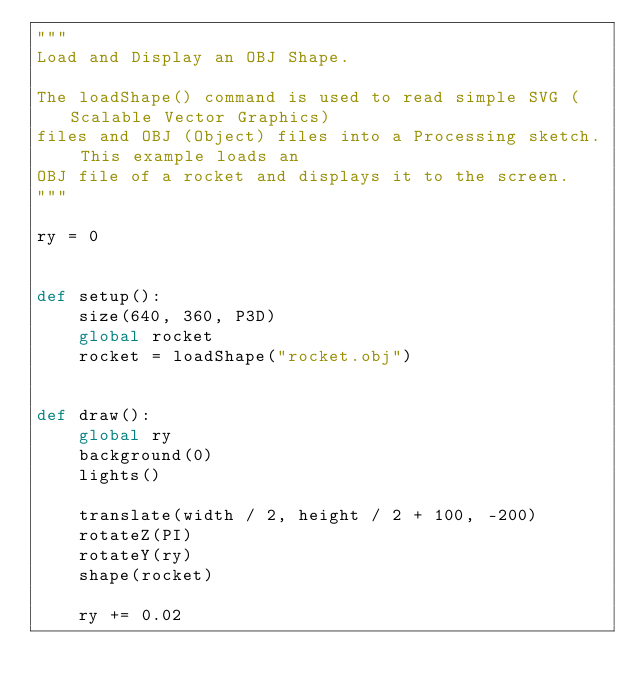Convert code to text. <code><loc_0><loc_0><loc_500><loc_500><_Python_>"""
Load and Display an OBJ Shape. 

The loadShape() command is used to read simple SVG (Scalable Vector Graphics)
files and OBJ (Object) files into a Processing sketch. This example loads an
OBJ file of a rocket and displays it to the screen. 
"""

ry = 0


def setup():
    size(640, 360, P3D)
    global rocket
    rocket = loadShape("rocket.obj")


def draw():
    global ry
    background(0)
    lights()

    translate(width / 2, height / 2 + 100, -200)
    rotateZ(PI)
    rotateY(ry)
    shape(rocket)

    ry += 0.02

</code> 